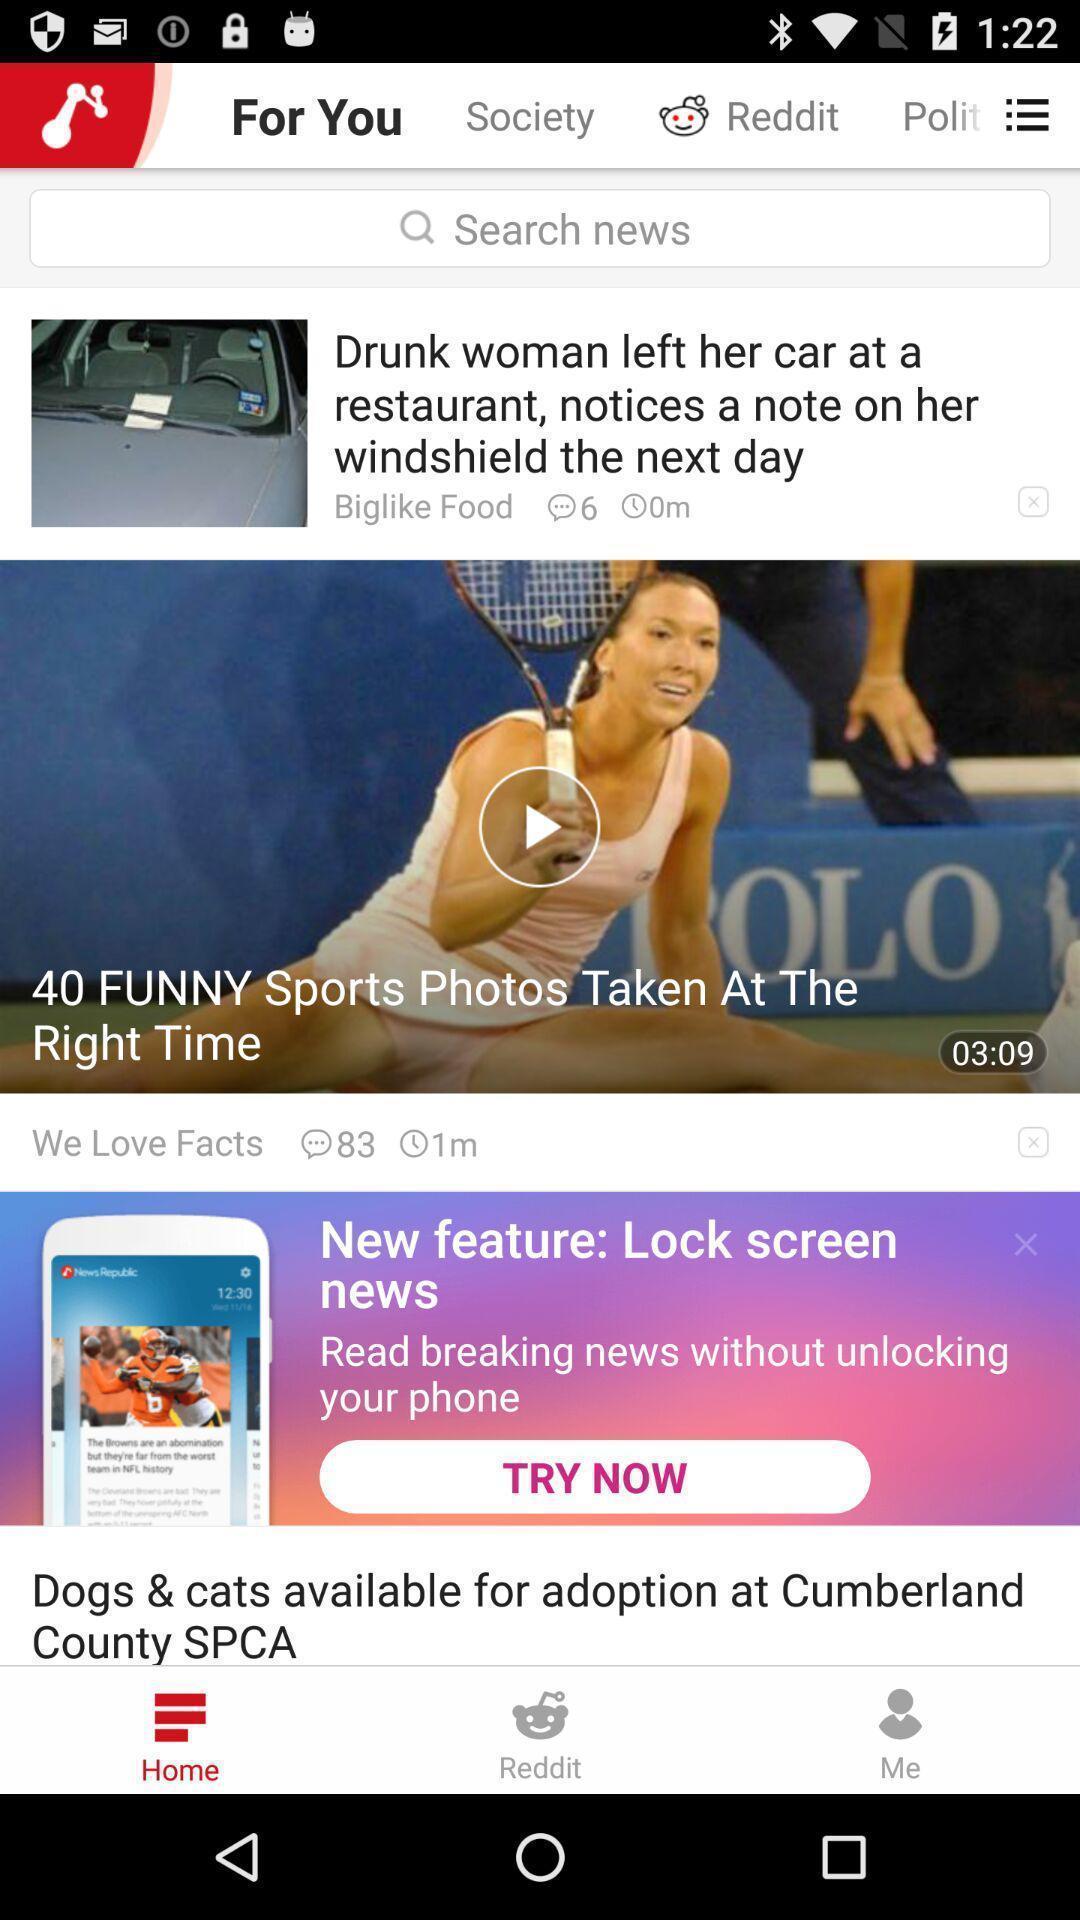Tell me about the visual elements in this screen capture. Screen displaying home page. 